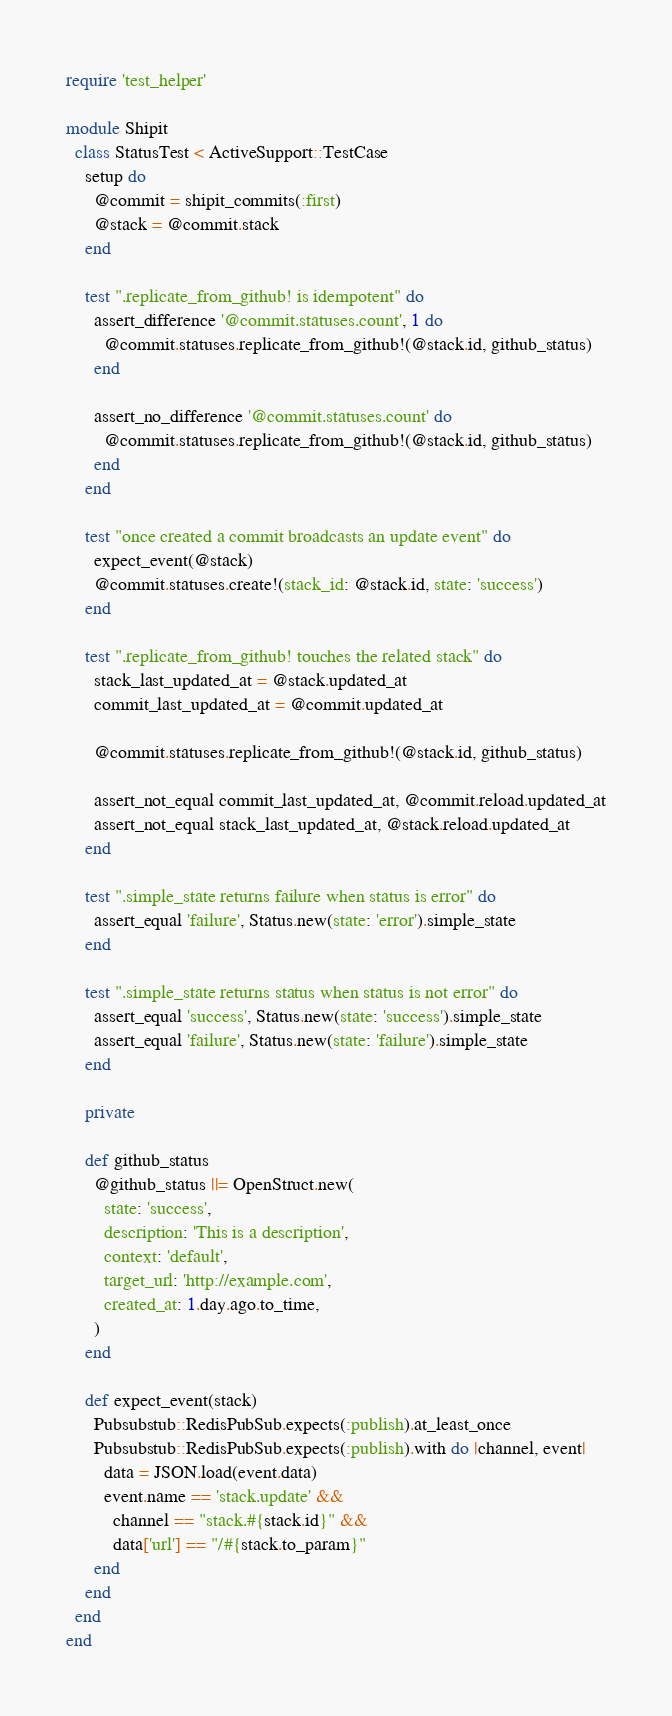Convert code to text. <code><loc_0><loc_0><loc_500><loc_500><_Ruby_>require 'test_helper'

module Shipit
  class StatusTest < ActiveSupport::TestCase
    setup do
      @commit = shipit_commits(:first)
      @stack = @commit.stack
    end

    test ".replicate_from_github! is idempotent" do
      assert_difference '@commit.statuses.count', 1 do
        @commit.statuses.replicate_from_github!(@stack.id, github_status)
      end

      assert_no_difference '@commit.statuses.count' do
        @commit.statuses.replicate_from_github!(@stack.id, github_status)
      end
    end

    test "once created a commit broadcasts an update event" do
      expect_event(@stack)
      @commit.statuses.create!(stack_id: @stack.id, state: 'success')
    end

    test ".replicate_from_github! touches the related stack" do
      stack_last_updated_at = @stack.updated_at
      commit_last_updated_at = @commit.updated_at

      @commit.statuses.replicate_from_github!(@stack.id, github_status)

      assert_not_equal commit_last_updated_at, @commit.reload.updated_at
      assert_not_equal stack_last_updated_at, @stack.reload.updated_at
    end

    test ".simple_state returns failure when status is error" do
      assert_equal 'failure', Status.new(state: 'error').simple_state
    end

    test ".simple_state returns status when status is not error" do
      assert_equal 'success', Status.new(state: 'success').simple_state
      assert_equal 'failure', Status.new(state: 'failure').simple_state
    end

    private

    def github_status
      @github_status ||= OpenStruct.new(
        state: 'success',
        description: 'This is a description',
        context: 'default',
        target_url: 'http://example.com',
        created_at: 1.day.ago.to_time,
      )
    end

    def expect_event(stack)
      Pubsubstub::RedisPubSub.expects(:publish).at_least_once
      Pubsubstub::RedisPubSub.expects(:publish).with do |channel, event|
        data = JSON.load(event.data)
        event.name == 'stack.update' &&
          channel == "stack.#{stack.id}" &&
          data['url'] == "/#{stack.to_param}"
      end
    end
  end
end
</code> 